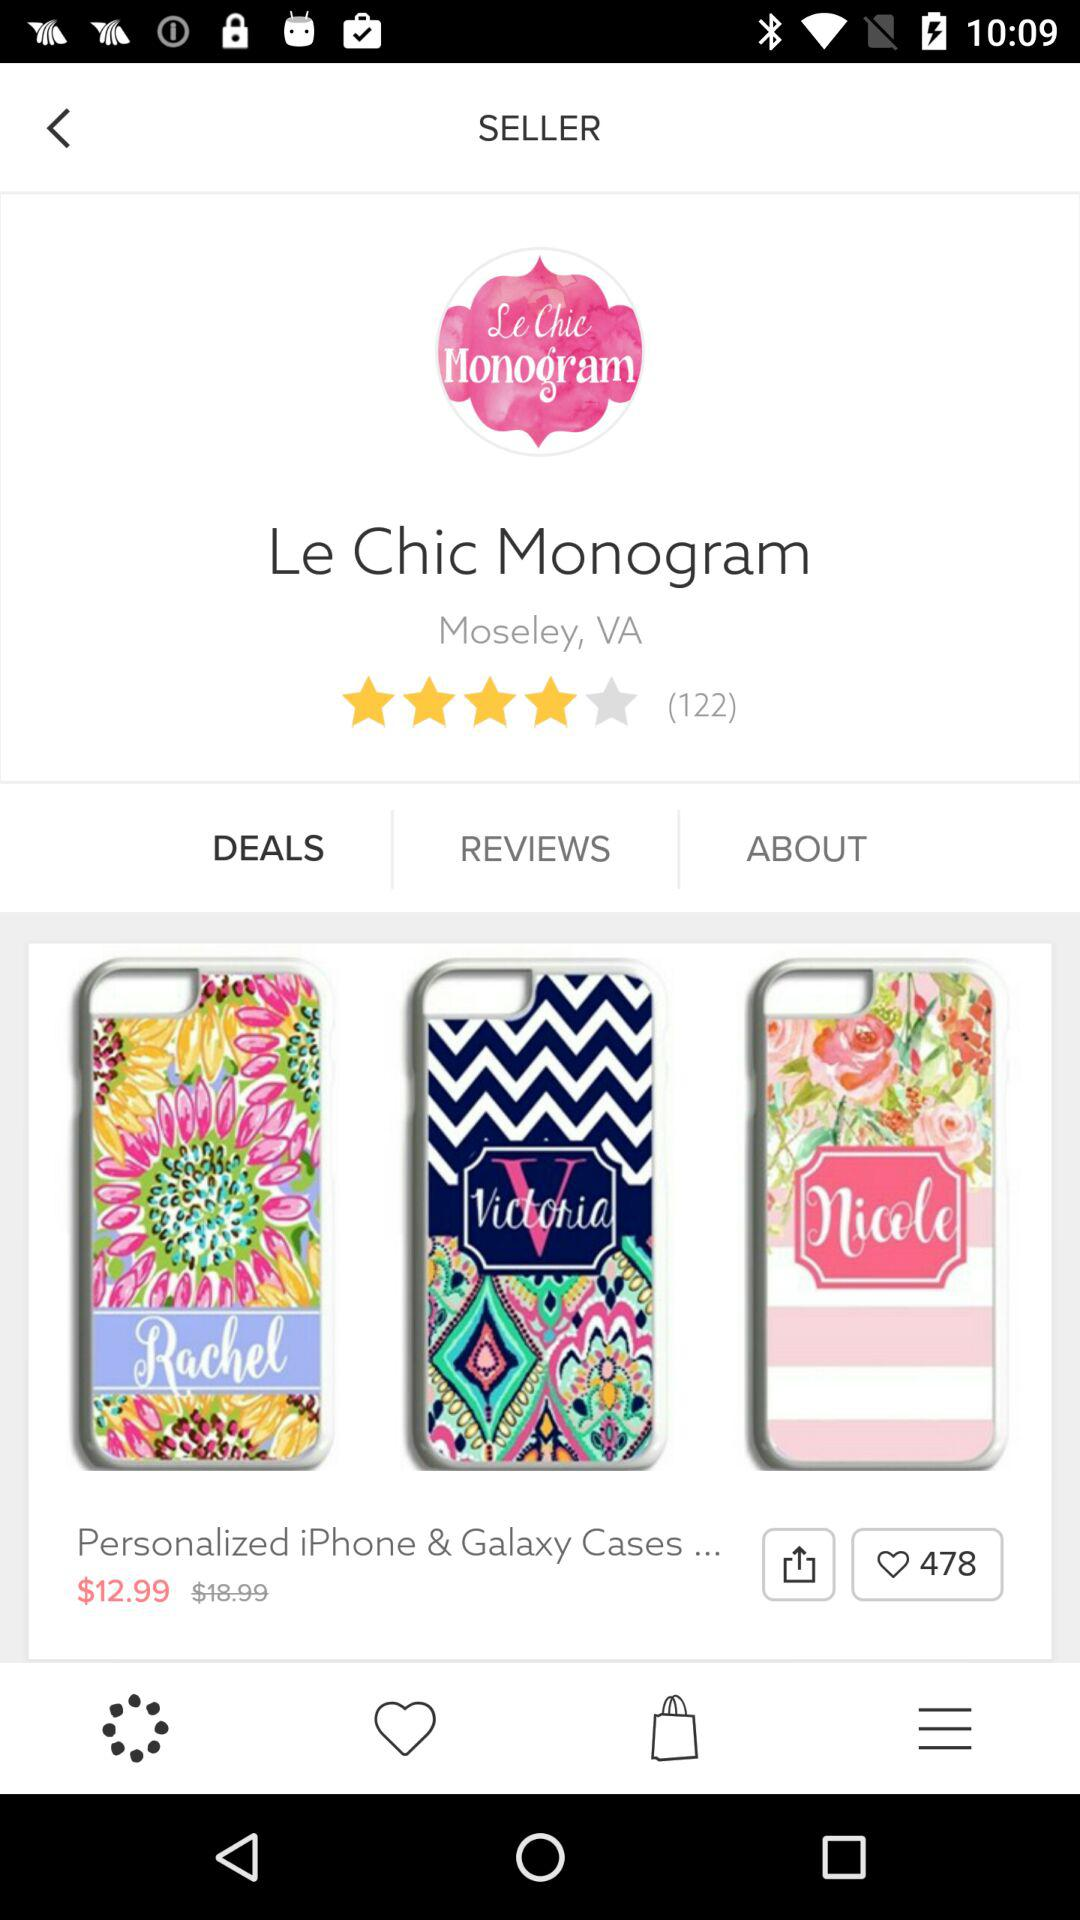Which option is selected? The selected option is "DEALS". 